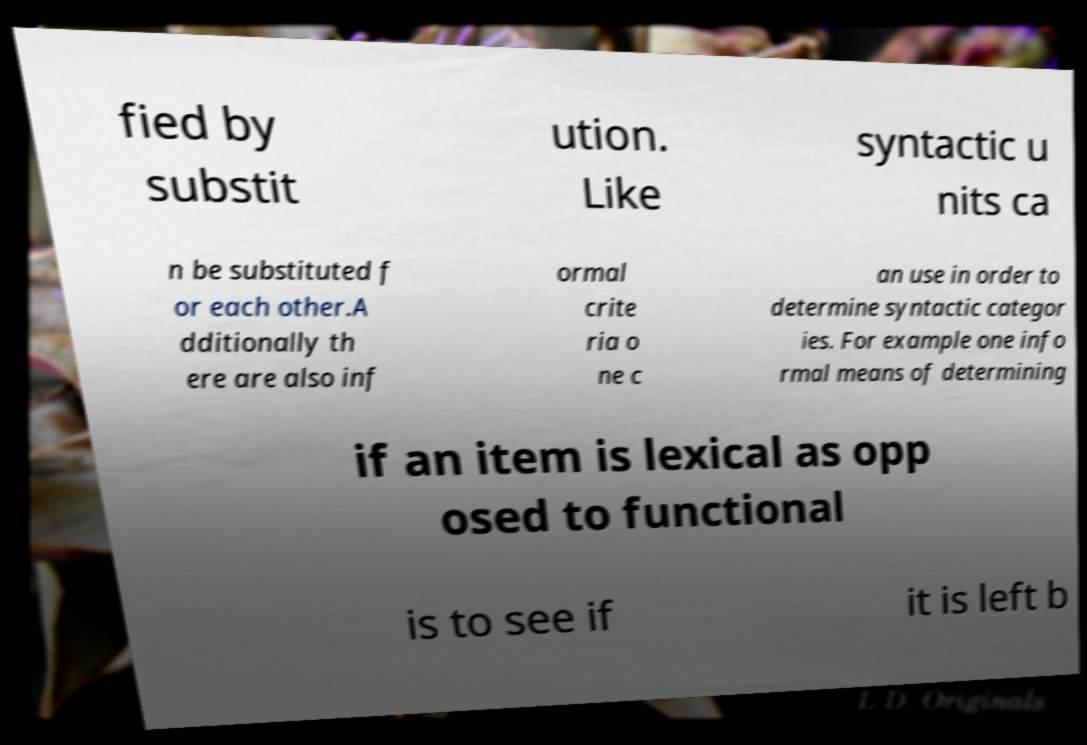Could you assist in decoding the text presented in this image and type it out clearly? fied by substit ution. Like syntactic u nits ca n be substituted f or each other.A dditionally th ere are also inf ormal crite ria o ne c an use in order to determine syntactic categor ies. For example one info rmal means of determining if an item is lexical as opp osed to functional is to see if it is left b 